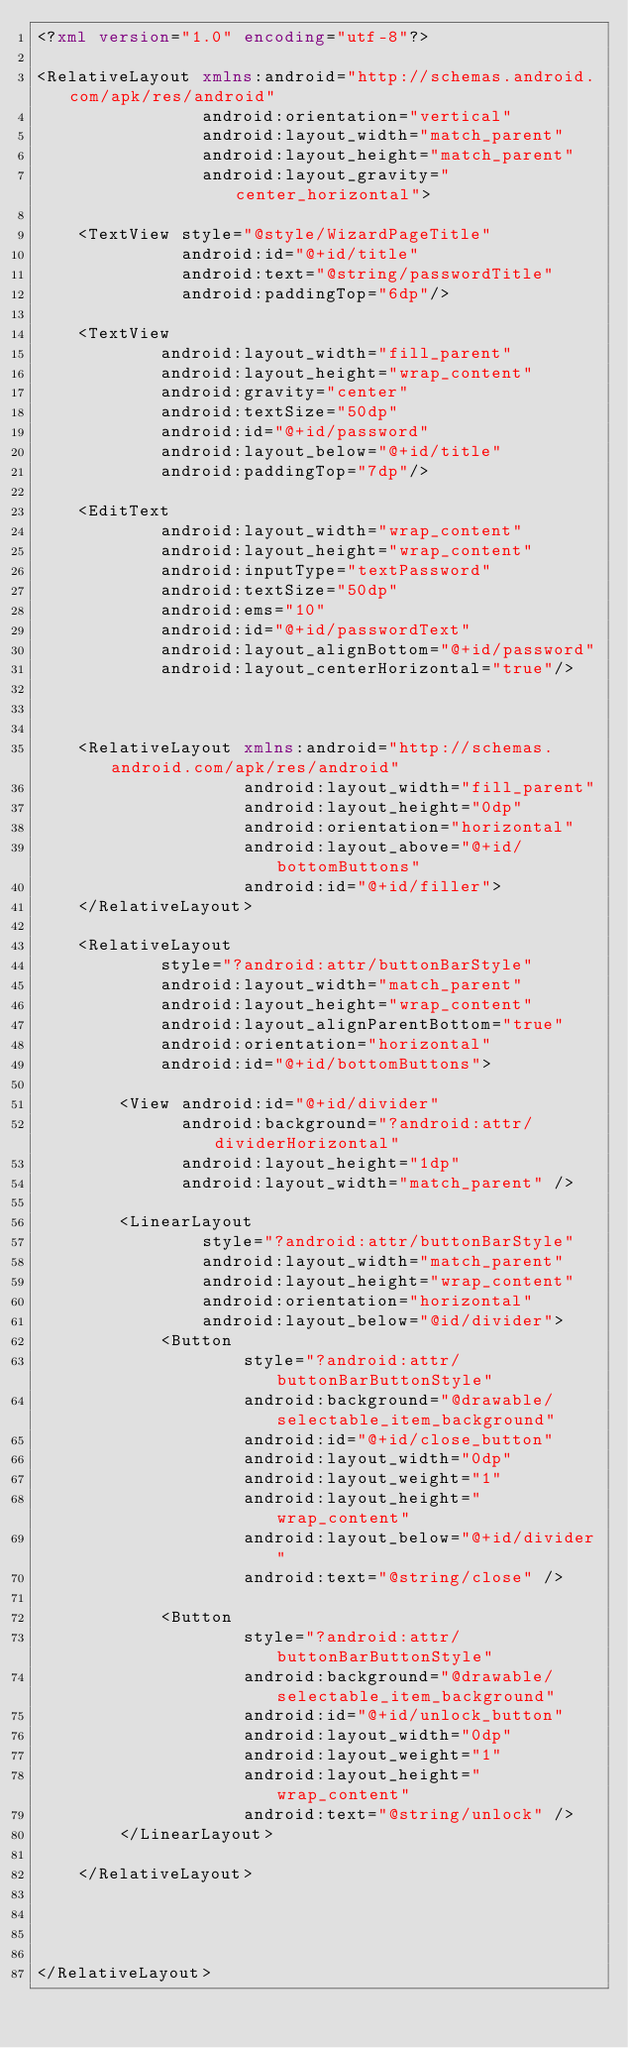<code> <loc_0><loc_0><loc_500><loc_500><_XML_><?xml version="1.0" encoding="utf-8"?>

<RelativeLayout xmlns:android="http://schemas.android.com/apk/res/android"
                android:orientation="vertical"
                android:layout_width="match_parent"
                android:layout_height="match_parent"
                android:layout_gravity="center_horizontal">

    <TextView style="@style/WizardPageTitle"
              android:id="@+id/title"
              android:text="@string/passwordTitle"
              android:paddingTop="6dp"/>

    <TextView
            android:layout_width="fill_parent"
            android:layout_height="wrap_content"
            android:gravity="center"
            android:textSize="50dp"
            android:id="@+id/password"
            android:layout_below="@+id/title"
            android:paddingTop="7dp"/>

    <EditText
            android:layout_width="wrap_content"
            android:layout_height="wrap_content"
            android:inputType="textPassword"
            android:textSize="50dp"
            android:ems="10"
            android:id="@+id/passwordText"
            android:layout_alignBottom="@+id/password"
            android:layout_centerHorizontal="true"/>



    <RelativeLayout xmlns:android="http://schemas.android.com/apk/res/android"
                    android:layout_width="fill_parent"
                    android:layout_height="0dp"
                    android:orientation="horizontal"
                    android:layout_above="@+id/bottomButtons"
                    android:id="@+id/filler">
    </RelativeLayout>

    <RelativeLayout
            style="?android:attr/buttonBarStyle"
            android:layout_width="match_parent"
            android:layout_height="wrap_content"
            android:layout_alignParentBottom="true"
            android:orientation="horizontal"
            android:id="@+id/bottomButtons">

        <View android:id="@+id/divider"
              android:background="?android:attr/dividerHorizontal"
              android:layout_height="1dp"
              android:layout_width="match_parent" />

        <LinearLayout
                style="?android:attr/buttonBarStyle"
                android:layout_width="match_parent"
                android:layout_height="wrap_content"
                android:orientation="horizontal"
                android:layout_below="@id/divider">
            <Button
                    style="?android:attr/buttonBarButtonStyle"
                    android:background="@drawable/selectable_item_background"
                    android:id="@+id/close_button"
                    android:layout_width="0dp"
                    android:layout_weight="1"
                    android:layout_height="wrap_content"
                    android:layout_below="@+id/divider"
                    android:text="@string/close" />

            <Button
                    style="?android:attr/buttonBarButtonStyle"
                    android:background="@drawable/selectable_item_background"
                    android:id="@+id/unlock_button"
                    android:layout_width="0dp"
                    android:layout_weight="1"
                    android:layout_height="wrap_content"
                    android:text="@string/unlock" />
        </LinearLayout>

    </RelativeLayout>




</RelativeLayout>
</code> 